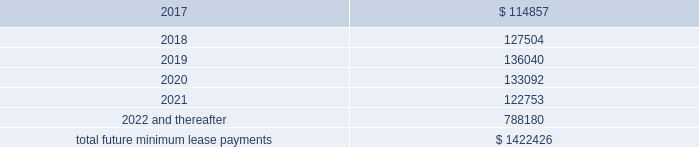Interest expense , net was $ 26.4 million , $ 14.6 million , and $ 5.3 million for the years ended december 31 , 2016 , 2015 and 2014 , respectively .
Interest expense includes the amortization of deferred financing costs , bank fees , capital and built-to-suit lease interest and interest expense under the credit and other long term debt facilities .
Amortization of deferred financing costs was $ 1.2 million , $ 0.8 million , and $ 0.6 million for the years ended december 31 , 2016 , 2015 and 2014 , respectively .
The company monitors the financial health and stability of its lenders under the credit and other long term debt facilities , however during any period of significant instability in the credit markets lenders could be negatively impacted in their ability to perform under these facilities .
Commitments and contingencies obligations under operating leases the company leases warehouse space , office facilities , space for its brand and factory house stores and certain equipment under non-cancelable operating leases .
The leases expire at various dates through 2033 , excluding extensions at the company 2019s option , and include provisions for rental adjustments .
The table below includes executed lease agreements for brand and factory house stores that the company did not yet occupy as of december 31 , 2016 and does not include contingent rent the company may incur at its stores based on future sales above a specified minimum or payments made for maintenance , insurance and real estate taxes .
The following is a schedule of future minimum lease payments for non-cancelable real property operating leases as of december 31 , 2016 as well as significant operating lease agreements entered into during the period after december 31 , 2016 through the date of this report : ( in thousands ) .
Included in selling , general and administrative expense was rent expense of $ 109.0 million , $ 83.0 million and $ 59.0 million for the years ended december 31 , 2016 , 2015 and 2014 , respectively , under non-cancelable operating lease agreements .
Included in these amounts was contingent rent expense of $ 13.0 million , $ 11.0 million and $ 11.0 million for the years ended december 31 , 2016 , 2015 and 2014 , respectively .
Sports marketing and other commitments within the normal course of business , the company enters into contractual commitments in order to promote the company 2019s brand and products .
These commitments include sponsorship agreements with teams and athletes on the collegiate and professional levels , official supplier agreements , athletic event sponsorships and other marketing commitments .
The following is a schedule of the company 2019s future minimum payments under its sponsorship and other marketing agreements as of december 31 .
What was the percentage change in rent expenses included in selling , general and administrative expense from 2014 to 2015? 
Computations: ((83.0 - 59.0) / 59.0)
Answer: 0.40678. 